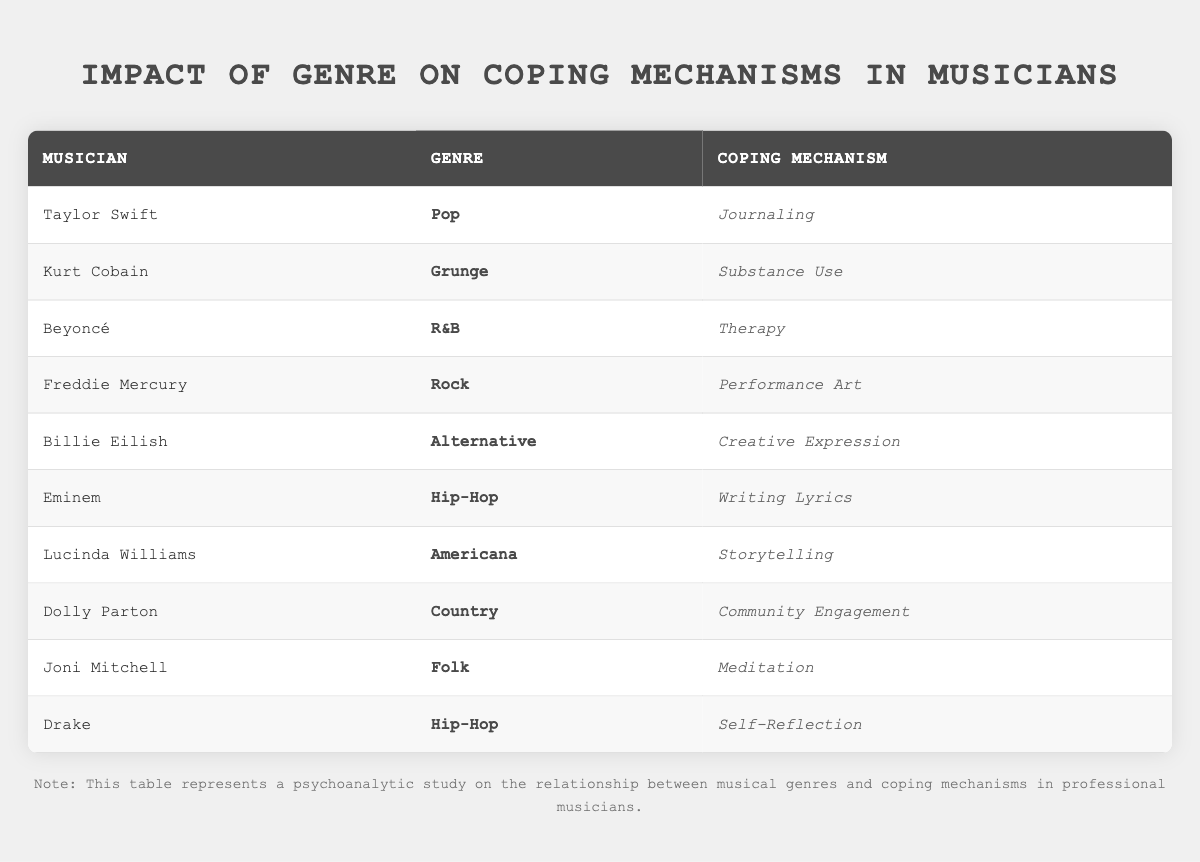What coping mechanism does Taylor Swift use? Taylor Swift is listed in the first row of the table, and the corresponding coping mechanism in her row is "Journaling."
Answer: Journaling Which genre does Freddie Mercury belong to? Freddie Mercury is found in the table under the row that shows his details, and the genre associated with him is "Rock."
Answer: Rock How many musicians in the table use 'Hip-Hop' as their genre? By looking at the genre column, we see two entries: Eminem and Drake, thereby summing them gives us 2 musicians.
Answer: 2 Is Eminem's coping mechanism 'Creative Expression'? Checking the row for Eminem reveals that his coping mechanism is "Writing Lyrics," so the statement is false.
Answer: No What is the coping mechanism for the Americana genre? The table shows that Lucinda Williams is associated with the Americana genre, and her coping mechanism is "Storytelling."
Answer: Storytelling What is the average number of coping mechanisms used by musicians across the table? Each musician in the table has one unique coping mechanism. There are 10 musicians, so the total is 10 and the average is also 10/10 = 1.
Answer: 1 How many different coping mechanisms are listed in the table? To find different coping mechanisms, we count unique entries in the coping mechanism column: Journaling, Substance Use, Therapy, Performance Art, Creative Expression, Writing Lyrics, Storytelling, Community Engagement, and Meditation, which totals 9.
Answer: 9 Do all musicians listed have a distinct coping mechanism? As we go through the table, we see that each musician has their own unique coping method, confirming that they are distinct.
Answer: Yes Which genre has the coping mechanism 'Substance Use'? Referring to the row for Kurt Cobain in the table, we see that he uses "Substance Use" and his genre is Grunge.
Answer: Grunge 